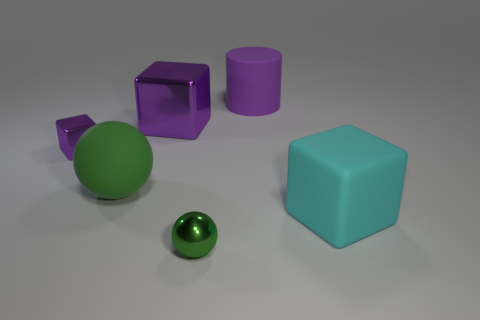There is another rubber thing that is the same shape as the small green object; what is its size?
Make the answer very short. Large. What is the size of the purple cylinder that is behind the cyan thing?
Offer a terse response. Large. Are there more large purple rubber objects to the left of the green matte object than large matte cylinders?
Your response must be concise. No. There is a large purple matte object; what shape is it?
Provide a short and direct response. Cylinder. There is a cube that is behind the tiny purple thing; is it the same color as the cube that is right of the large purple cylinder?
Provide a succinct answer. No. Does the big cyan thing have the same shape as the green rubber object?
Ensure brevity in your answer.  No. Is there anything else that is the same shape as the big metallic object?
Your answer should be very brief. Yes. Do the tiny sphere in front of the big green sphere and the big cyan block have the same material?
Make the answer very short. No. There is a rubber thing that is both behind the cyan matte block and in front of the cylinder; what is its shape?
Provide a succinct answer. Sphere. There is a large cube that is behind the big green matte thing; is there a big green matte sphere that is in front of it?
Provide a succinct answer. Yes. 